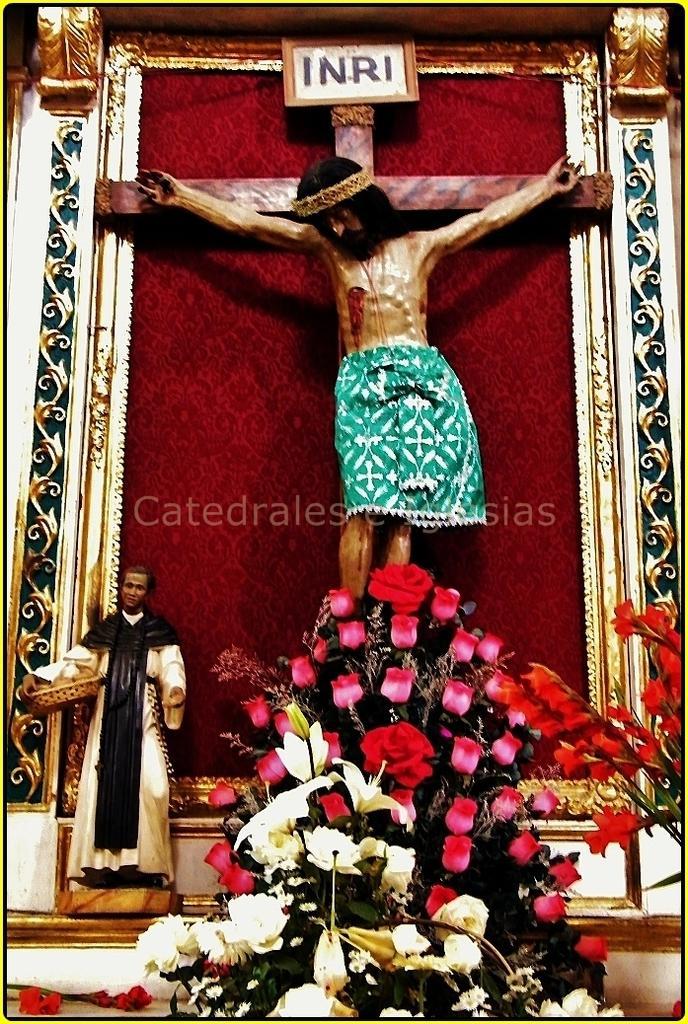Can you describe this image briefly? As we can see in the image there are different colors of flowers, statue and a person holding tray. 